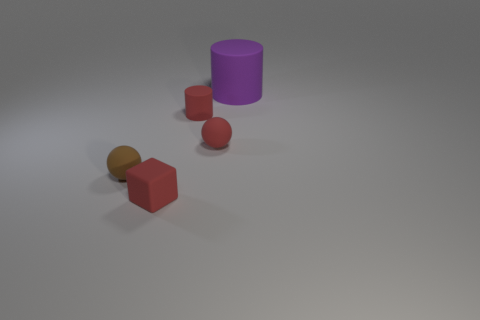Add 4 matte cubes. How many objects exist? 9 Subtract all spheres. How many objects are left? 3 Add 5 large blue shiny balls. How many large blue shiny balls exist? 5 Subtract 0 gray spheres. How many objects are left? 5 Subtract all small things. Subtract all brown spheres. How many objects are left? 0 Add 1 tiny red objects. How many tiny red objects are left? 4 